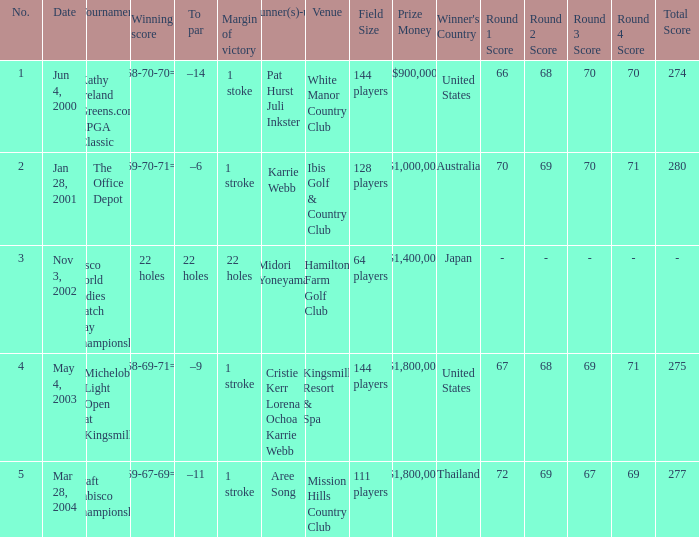Where is the margin of victory dated mar 28, 2004? 1 stroke. 